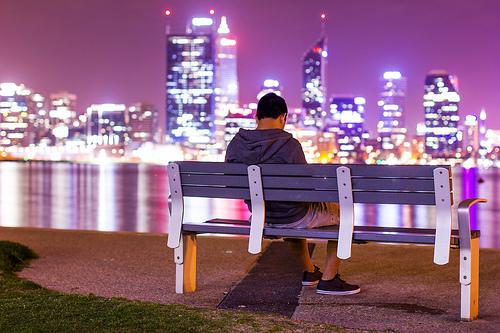What kind of sentiment or mood does the image evoke? The image evokes a peaceful and serene mood with a man sitting on a bench by the water, looking at the brightly lit city skyline. What is the color of the sky in the image and is there any reflection of the sky on the water?  The sky is purple with a city skyline, and there is a purple sky water reflection in the image. Explain the setting surrounding the bench in the image. The bench is situated on cement, has green grass nearby, and is next to the water, with a skyline of tall lit-up buildings in the distance. Mention one peculiar aspect about the skyline in the image. The skyline is bright with tall buildings lit up at night and purple in color which makes it look unreal. Describe the person sitting on the bench and what they are wearing. The man sitting on the bench has short, dark hair, is wearing a dark grey hoody, black shoes, and shorts. Explain the color and style of the man's shoes. The shoes of the man are black in color and appear to be a simple tennis shoe design. Where are the skyscrapers located in the image, and what is their relation to the water? The skyscrapers are behind the water and can be seen in the distance with the purple sky as the backdrop. Can you identify a blue-lighted skyscraper? No, it's not mentioned in the image. Can you find the pink skyline in the image? The skyline is described as purple and bright but never pink. This instruction asks for a non-existent feature in the image. Is the man wearing a green hoody? The instructions mention that the man is wearing a hoody and the hoody is dark grey. There is no mention of a green hoody. 